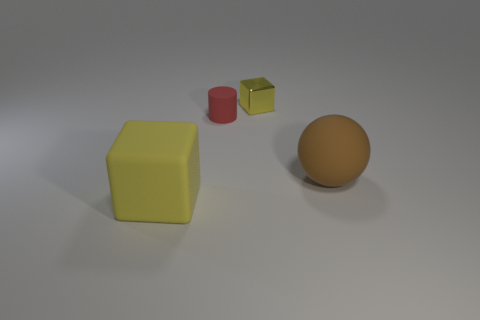Does the cylinder have the same material as the yellow cube that is left of the yellow metallic block?
Your response must be concise. Yes. Is the number of small cylinders that are behind the small red rubber cylinder the same as the number of small red rubber objects in front of the tiny shiny block?
Ensure brevity in your answer.  No. What material is the small block?
Your response must be concise. Metal. There is a matte object that is the same size as the matte cube; what color is it?
Provide a short and direct response. Brown. Are there any rubber objects that are behind the thing that is on the left side of the matte cylinder?
Offer a very short reply. Yes. What number of cylinders are large yellow objects or matte objects?
Your response must be concise. 1. How big is the yellow block behind the big rubber thing that is to the right of the big yellow matte object to the left of the yellow shiny object?
Make the answer very short. Small. There is a small red rubber cylinder; are there any big yellow blocks to the left of it?
Provide a short and direct response. Yes. The small shiny thing that is the same color as the large block is what shape?
Offer a terse response. Cube. What number of objects are either rubber objects that are right of the red matte cylinder or yellow metal cubes?
Your answer should be compact. 2. 